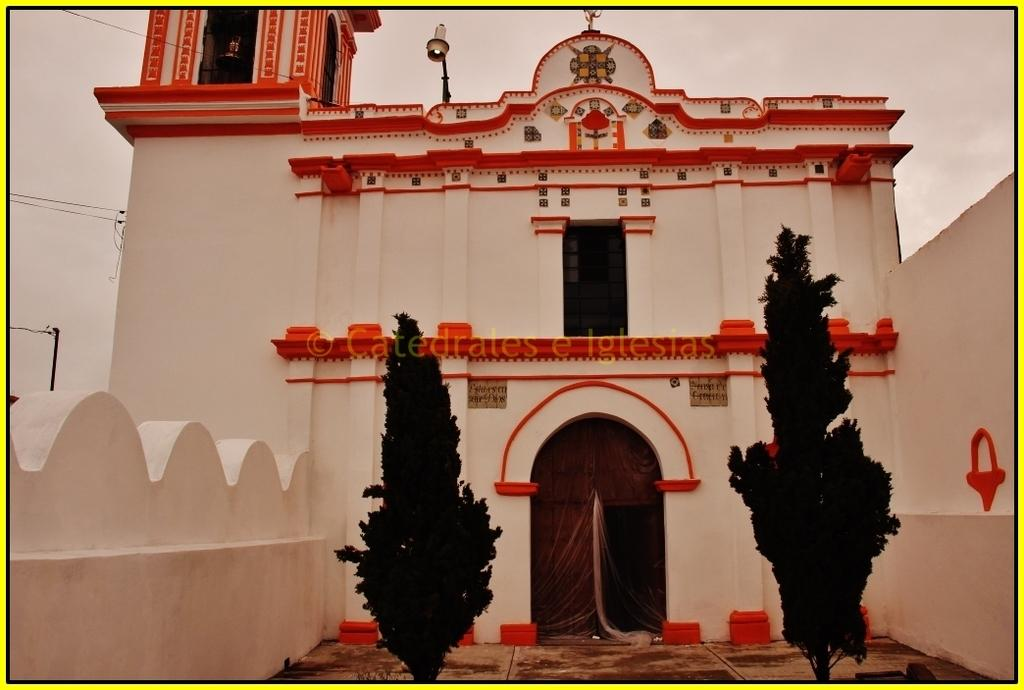What can be seen in the foreground of the image? There are two trees in the foreground of the image. What is visible in the background of the image? There is a building, a light, a wall, a pole, cables, and clouds visible in the background of the image. What type of pencil can be seen on the ground in the image? There is no pencil present in the image. How many steps are visible in the image? There are no steps visible in the image. 